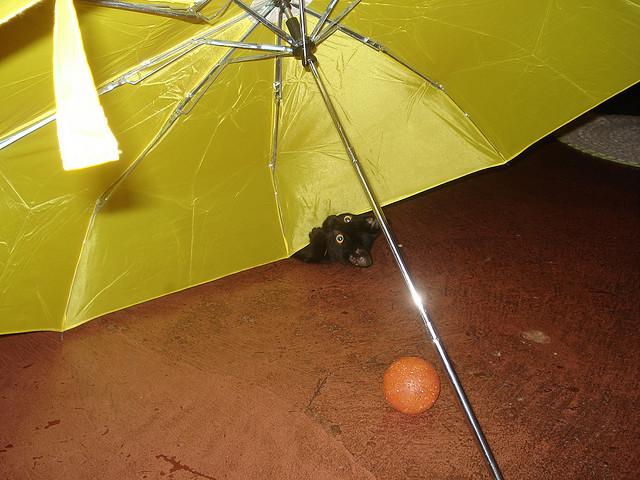What color is the umbrella?
Answer briefly. Yellow. Does the kitten think the umbrella is a toy?
Give a very brief answer. Yes. Is the cat a tabby?
Give a very brief answer. No. 